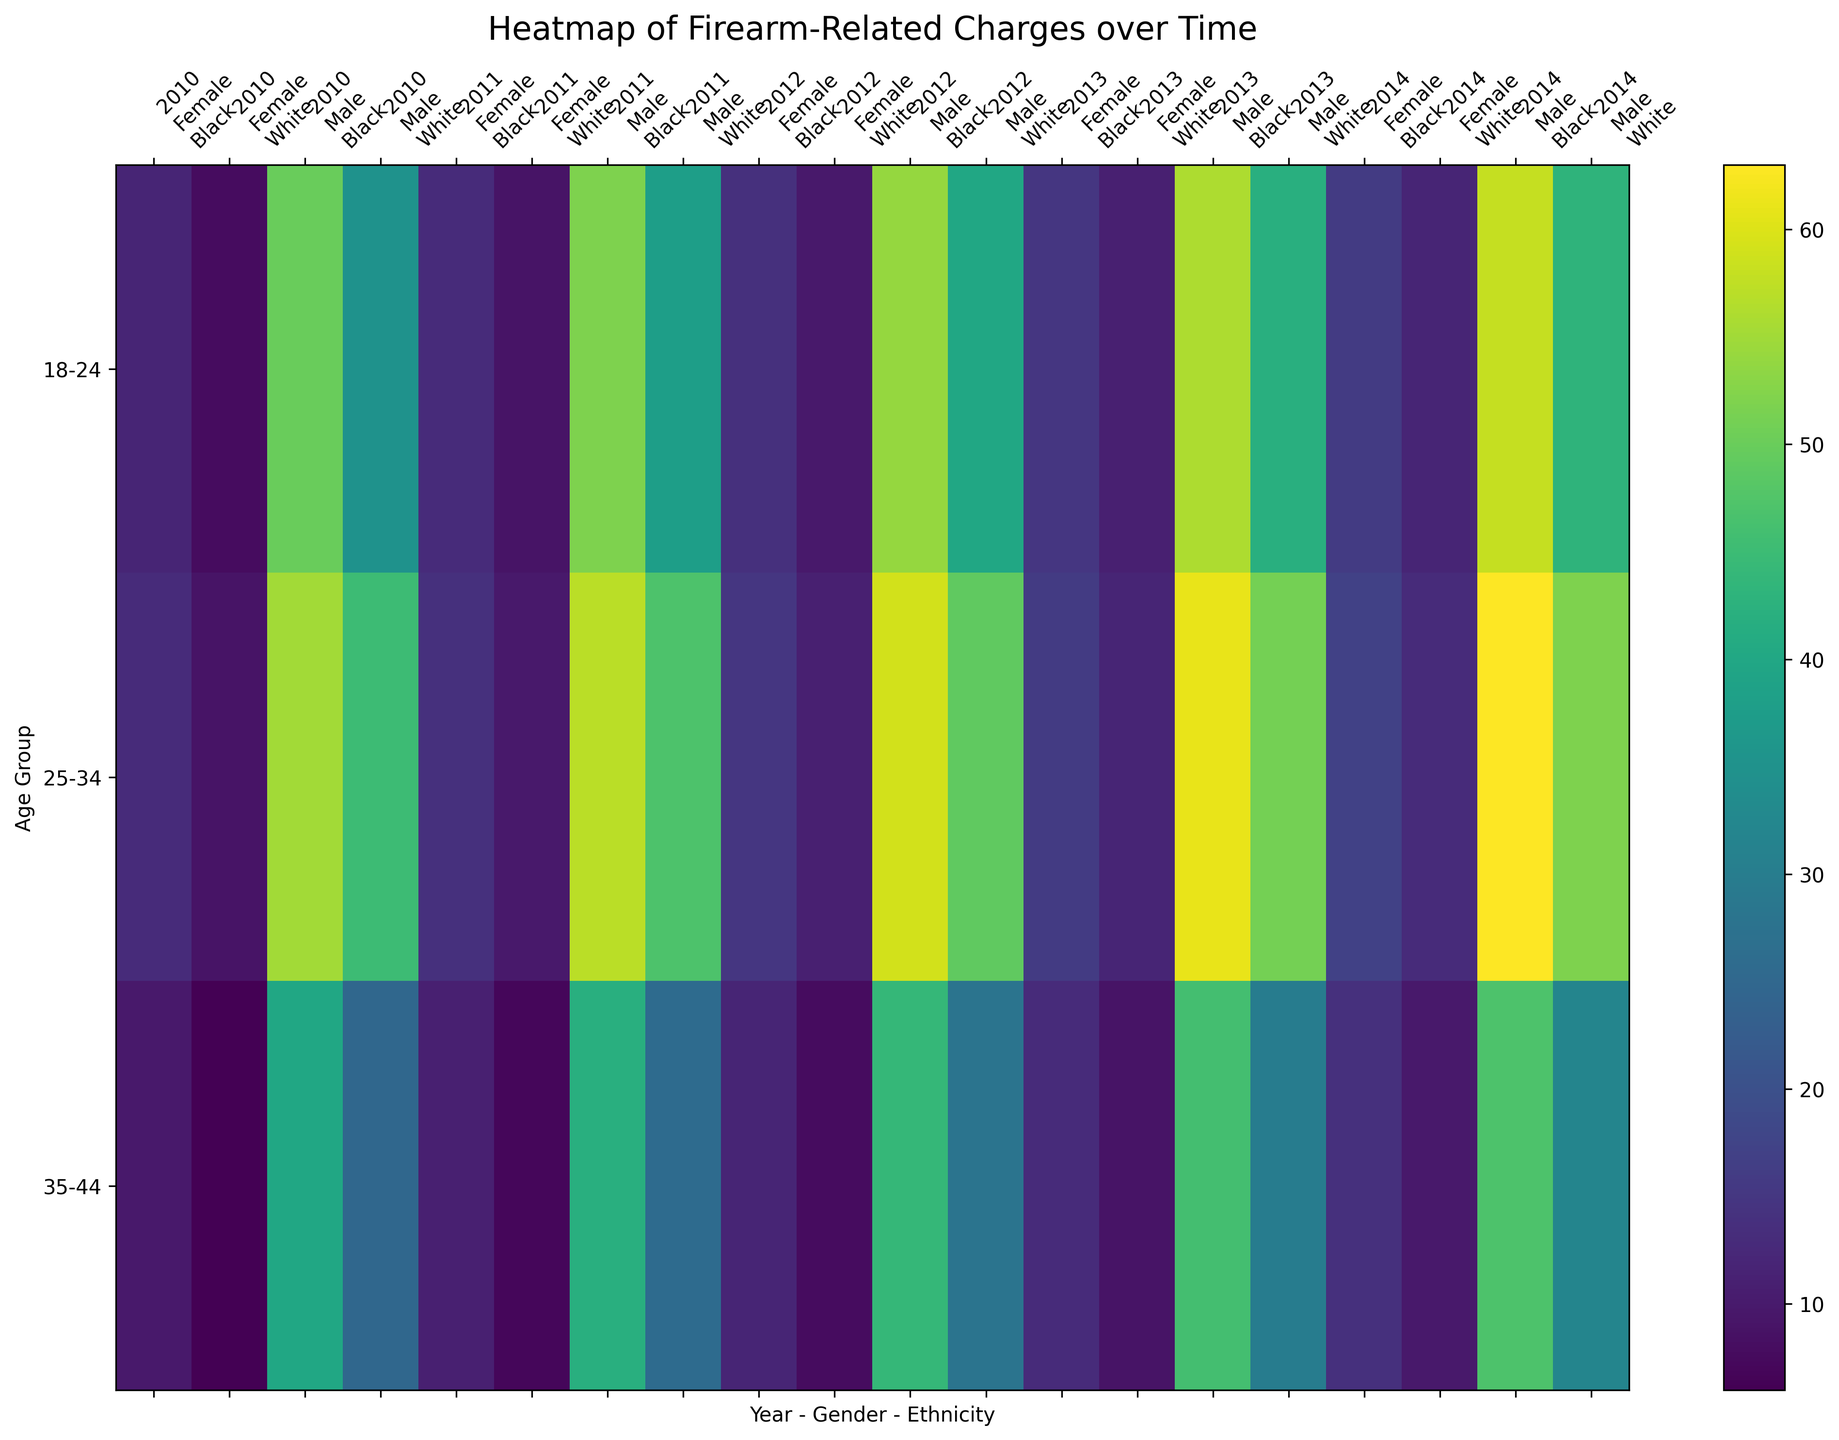Which age group saw the most firearm-related charges in 2013? Look for the color intensity for the charges in 2013, identify the row with the most intense color. The 18-24 Male Black group shows the highest intensity.
Answer: 18-24 Male Black Compare the number of charges for Black males aged 25-34 in 2012 and 2014. Which year had more charges? Compare the color intensity in the 2012 and 2014 columns for Black males aged 25-34. The color is more intense in 2014.
Answer: 2014 Which gender and ethnicity combination had the least charges in 2010 for 35-44 age group? Look at the 2010 columns and check the color intensity for the 35-44 age group. The least intense color is for White females.
Answer: Female White How did charges for Black females aged 18-24 change from 2010 to 2014? Observe the color intensity progression for Black females aged 18-24 over the years from 2010 to 2014. The intensity increases indicating more charges in 2014.
Answer: Increased In 2011, which age group had more charges, 18-24 or 35-44, across all genders and ethnicities? Compare the color intensities of the age groups 18-24 and 35-44 columns in 2011. The 18-24 age group has more intensity overall.
Answer: 18-24 Which had more charges on average from 2010-2014, White males aged 25-34 or Black males aged 35-44? Calculate the average intensity (visually estimate) for White males aged 25-34 and Black males aged 35-44 across the years. White males aged 25-34 show higher intensity.
Answer: White males aged 25-34 Which ethnic group had a higher difference in charges between the ages of 25-34 and 35-44 in 2014 for males? Compare the color intensity difference for charges between ages 25-34 and 35-44 for males in 2014. Black males show a higher difference.
Answer: Black In 2013, which gender and ethnicity in the 18-24 age group saw a higher conviction rate, considering both gender and ethnicity? Examine the color intensity related to convictions in 2013 for the 18-24 age group across gender and ethnicity. Black males show the highest conviction rate.
Answer: Male Black For Black females aged 25-34, did the number of charges consistently increase, decrease, or fluctuate between 2010 and 2014? Observe the pattern in color intensity for Black females aged 25-34 from 2010 to 2014. The pattern shows a consistent increase in intensity.
Answer: Increase Sum the charges for White females in 2012 across all age groups. Sum the estimated values for White females in 2012 across 18-24, 25-34, and 35-44 age groups by examining color intensity and counting any visible numbers if present. The sum is approximately: 10 (18-24) + 11 (25-34) + 8 (35-44). So, 10 + 11 + 8 = 29.
Answer: 29 Calculate the average number of convictions for Black males aged 18-24 between 2010 and 2012. Sum the convictions for Black males aged 18-24 for 2010 (30), 2011 (31), and 2012 (33), then divide by 3. (30 + 31 + 33) / 3 = 31.33.
Answer: 31.33 